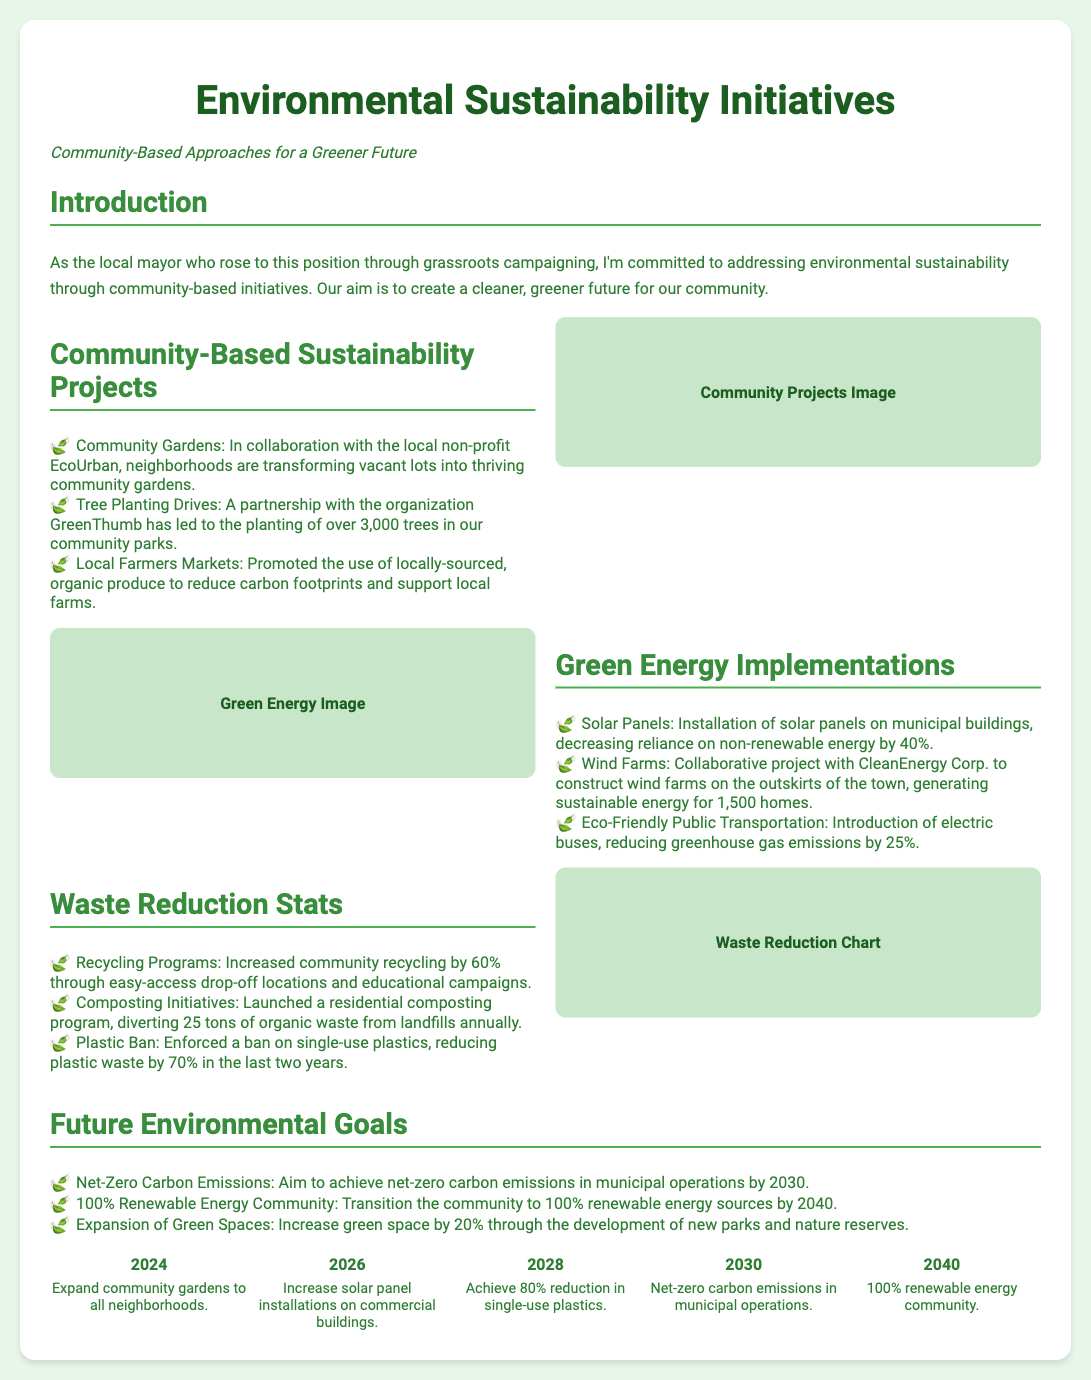What is the title of the presentation? The title of the presentation is shown prominently at the top of the slide.
Answer: Environmental Sustainability Initiatives How many trees have been planted in community parks? The number of trees planted is listed in the community-based sustainability projects section.
Answer: 3,000 trees What year do we aim to achieve net-zero carbon emissions? The goal for net-zero carbon emissions is specified in the future environmental goals section.
Answer: 2030 What initiative has diverted 25 tons of organic waste from landfills? This initiative is mentioned in the waste reduction stats section.
Answer: Composting Initiatives By what percentage has community recycling increased? The percentage increase in community recycling is detailed in the waste reduction stats.
Answer: 60% How many electric buses have been introduced? The document mentions the introduction of electric buses under green energy implementations but does not specify how many.
Answer: (No specific number given) What is the future goal for the renewable energy community? The objective for the community's renewable energy transition is stated in the future environmental goals section.
Answer: 100% renewable energy sources by 2040 What is the name of the organization partnered with for tree planting drives? The organization involved in tree planting is mentioned in the community-based sustainability projects section.
Answer: GreenThumb What is the timeline year for expanding community gardens? The timeline item specifying the expansion of community gardens is highlighted.
Answer: 2024 